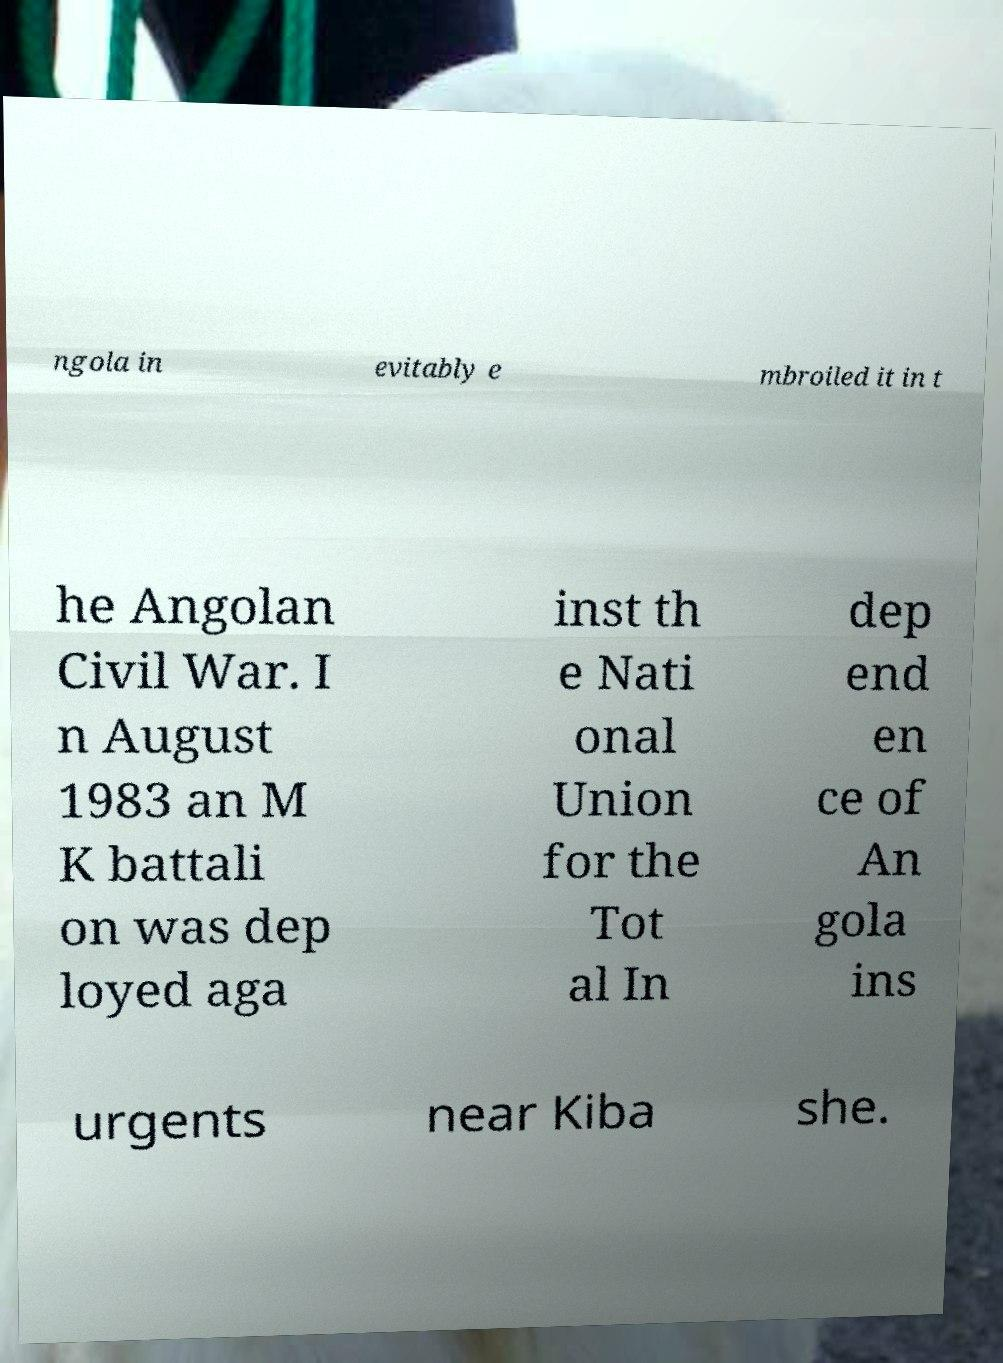There's text embedded in this image that I need extracted. Can you transcribe it verbatim? ngola in evitably e mbroiled it in t he Angolan Civil War. I n August 1983 an M K battali on was dep loyed aga inst th e Nati onal Union for the Tot al In dep end en ce of An gola ins urgents near Kiba she. 